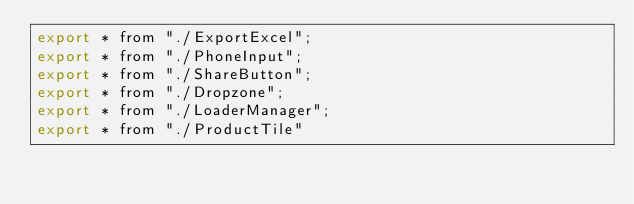Convert code to text. <code><loc_0><loc_0><loc_500><loc_500><_JavaScript_>export * from "./ExportExcel";
export * from "./PhoneInput";
export * from "./ShareButton";
export * from "./Dropzone";
export * from "./LoaderManager";
export * from "./ProductTile"</code> 